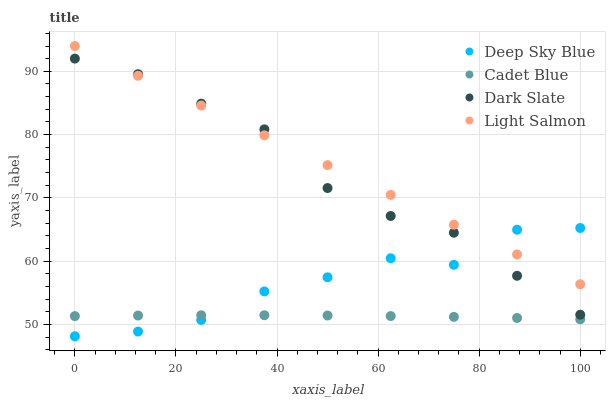Does Cadet Blue have the minimum area under the curve?
Answer yes or no. Yes. Does Light Salmon have the maximum area under the curve?
Answer yes or no. Yes. Does Light Salmon have the minimum area under the curve?
Answer yes or no. No. Does Cadet Blue have the maximum area under the curve?
Answer yes or no. No. Is Light Salmon the smoothest?
Answer yes or no. Yes. Is Deep Sky Blue the roughest?
Answer yes or no. Yes. Is Cadet Blue the smoothest?
Answer yes or no. No. Is Cadet Blue the roughest?
Answer yes or no. No. Does Deep Sky Blue have the lowest value?
Answer yes or no. Yes. Does Cadet Blue have the lowest value?
Answer yes or no. No. Does Light Salmon have the highest value?
Answer yes or no. Yes. Does Cadet Blue have the highest value?
Answer yes or no. No. Is Cadet Blue less than Dark Slate?
Answer yes or no. Yes. Is Light Salmon greater than Cadet Blue?
Answer yes or no. Yes. Does Deep Sky Blue intersect Cadet Blue?
Answer yes or no. Yes. Is Deep Sky Blue less than Cadet Blue?
Answer yes or no. No. Is Deep Sky Blue greater than Cadet Blue?
Answer yes or no. No. Does Cadet Blue intersect Dark Slate?
Answer yes or no. No. 